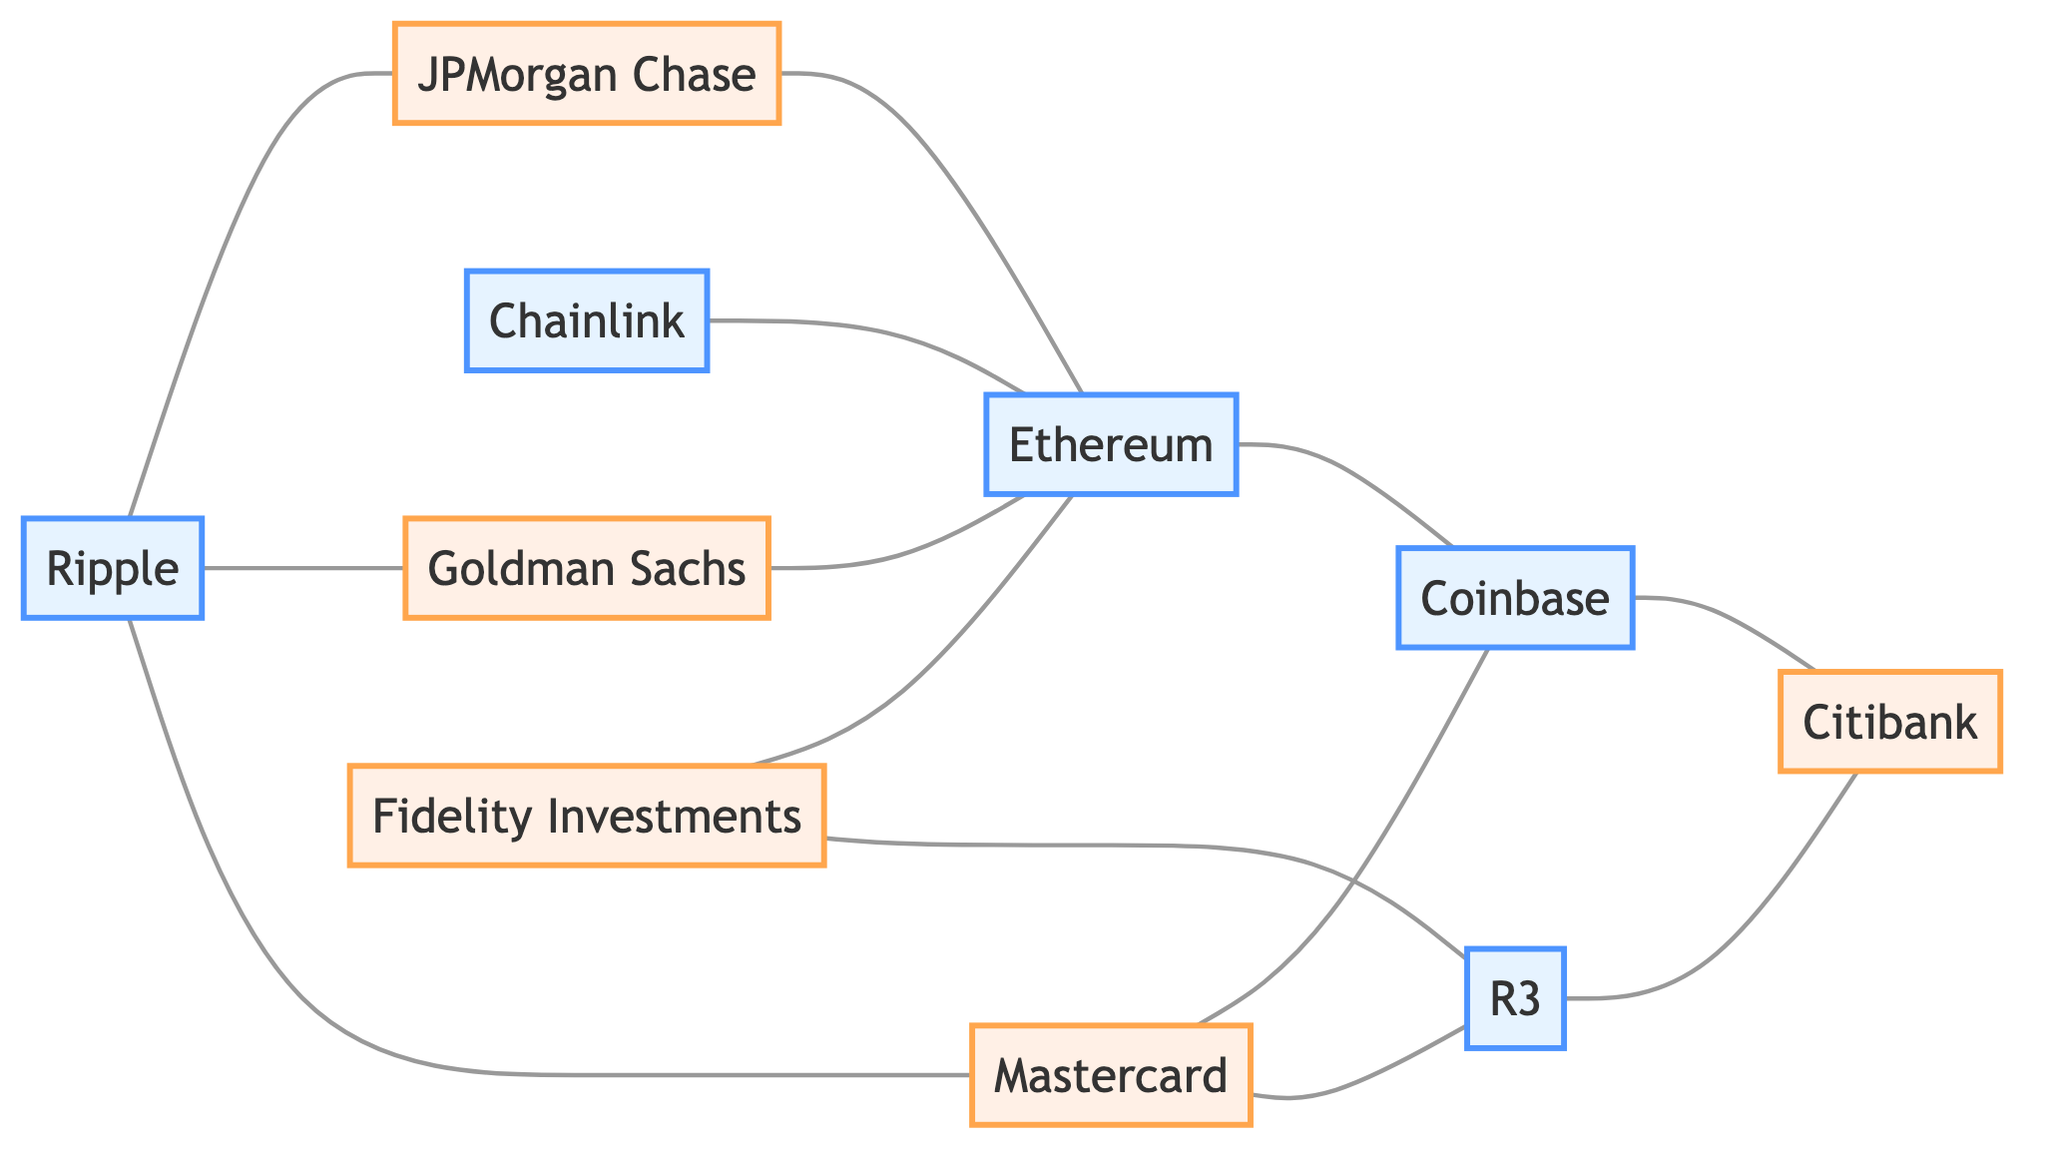What is the total number of nodes in the diagram? The diagram has a total of ten nodes representing different blockchain startups and established financial institutions.
Answer: 10 Which financial institution is connected to Ripple? Ripple is directly connected to three entities: JPMorgan Chase, Goldman Sachs, and Mastercard. Thus, one of them is JPMorgan Chase.
Answer: JPMorgan Chase How many edges are connected to Ethereum? Ethereum has four edges connecting it to JPMorgan Chase, Goldman Sachs, Coinbase, and Fidelity Investments.
Answer: 4 What startup is connected to both JPMorgan Chase and Citibank? By examining the connections, the only startup that connects both financial institutions is Ethereum.
Answer: Ethereum Which blockchain startup has the most connections? Upon reviewing the diagram, Ethereum is connected to four different entities, making it the startup with the most edges.
Answer: Ethereum How many unique financial institutions are connected to the blockchain startups? The connections show six unique financial institutions: JPMorgan Chase, Goldman Sachs, Fidelity Investments, Mastercard, Citibank, and R3.
Answer: 6 What is the relationship between Chainlink and Ethereum? Chainlink is directly connected to Ethereum, indicating a cooperative relationship within the blockchain ecosystem.
Answer: Directly connected Which two nodes have the longest path between them considering the connections? The longest path can be traced from Ripple through multiple connections ultimately leading to Citibank, indicating a complex relationship.
Answer: Ripple to Citibank How many financial institutions connect to R3? The diagram indicates that R3 has two connections, with Fidelity Investments and Citibank.
Answer: 2 Which blockchain startup directly connects to Mastercard? Ripple is the blockchain startup that has a direct connection with Mastercard in the diagram.
Answer: Ripple 